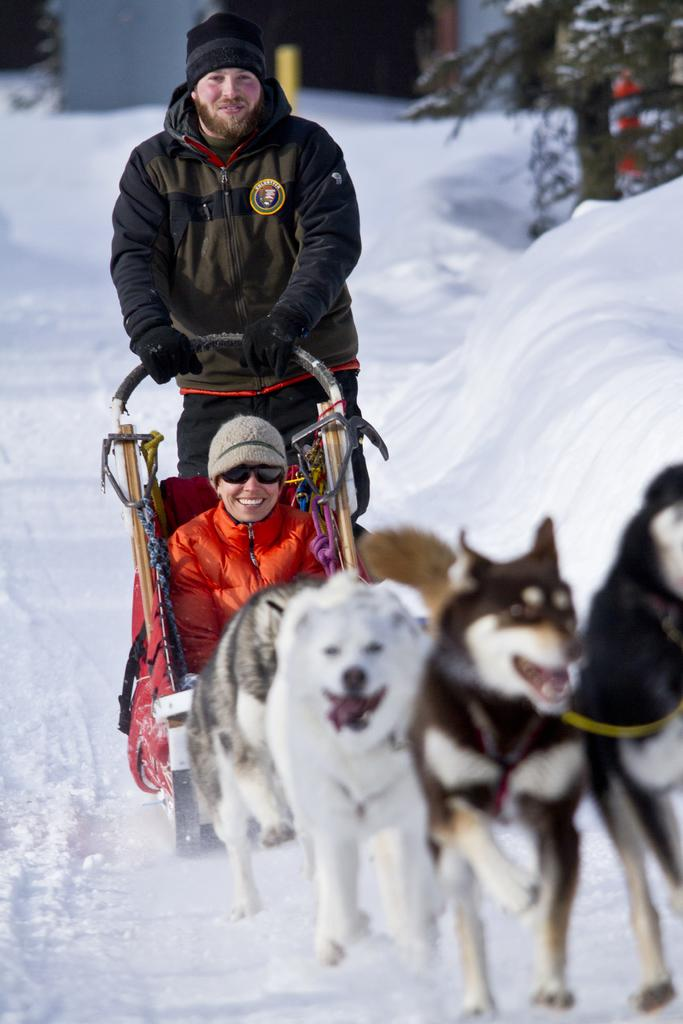How many people are in the image? There are two people in the image. What other living beings are present in the image? There are dogs in the image. What type of terrain is visible in the image? The people and dogs are on the snow. What type of card is being used to shovel the snow in the image? There is no card or shoveling activity present in the image; the people and dogs are simply on the snow. 